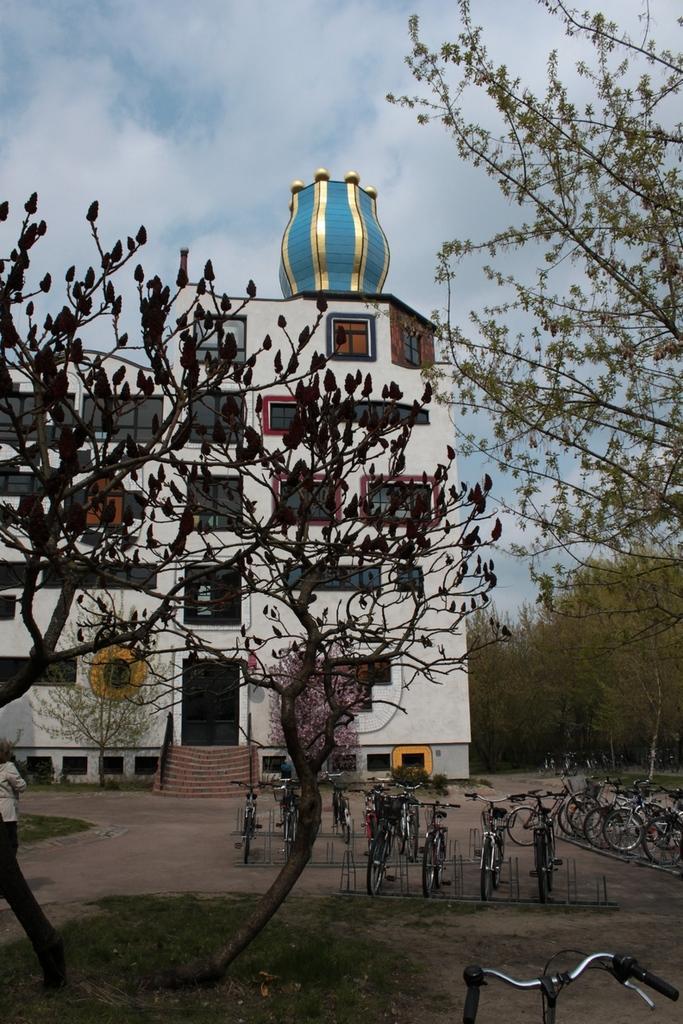How would you summarize this image in a sentence or two? In this image we can see a building with glass windows, doors, steps and other objects. At the bottom of the image there are some bicycles, trees and grass. On the right side of the image there are some trees and bicycles. In the background of the image there is the sky. 